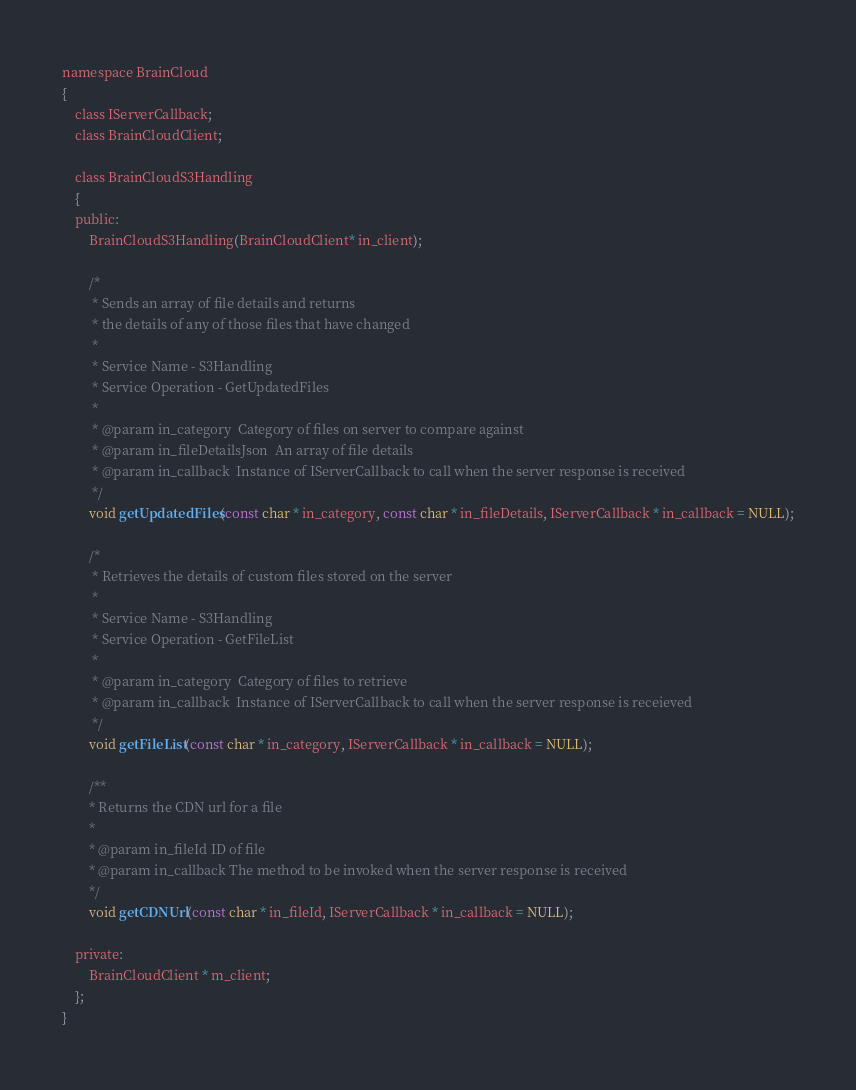<code> <loc_0><loc_0><loc_500><loc_500><_C_>namespace BrainCloud
{
    class IServerCallback;
    class BrainCloudClient;

    class BrainCloudS3Handling
    {
    public:
        BrainCloudS3Handling(BrainCloudClient* in_client);

        /*
         * Sends an array of file details and returns
         * the details of any of those files that have changed
         *
         * Service Name - S3Handling
         * Service Operation - GetUpdatedFiles
         *
         * @param in_category  Category of files on server to compare against
         * @param in_fileDetailsJson  An array of file details
         * @param in_callback  Instance of IServerCallback to call when the server response is received
         */
        void getUpdatedFiles(const char * in_category, const char * in_fileDetails, IServerCallback * in_callback = NULL);

        /*
         * Retrieves the details of custom files stored on the server
         *
         * Service Name - S3Handling
         * Service Operation - GetFileList
         *
         * @param in_category  Category of files to retrieve
         * @param in_callback  Instance of IServerCallback to call when the server response is receieved
         */
        void getFileList(const char * in_category, IServerCallback * in_callback = NULL);

		/**
		* Returns the CDN url for a file
		*
		* @param in_fileId ID of file
		* @param in_callback The method to be invoked when the server response is received
		*/
		void getCDNUrl(const char * in_fileId, IServerCallback * in_callback = NULL);

    private:
        BrainCloudClient * m_client;
    };
}</code> 